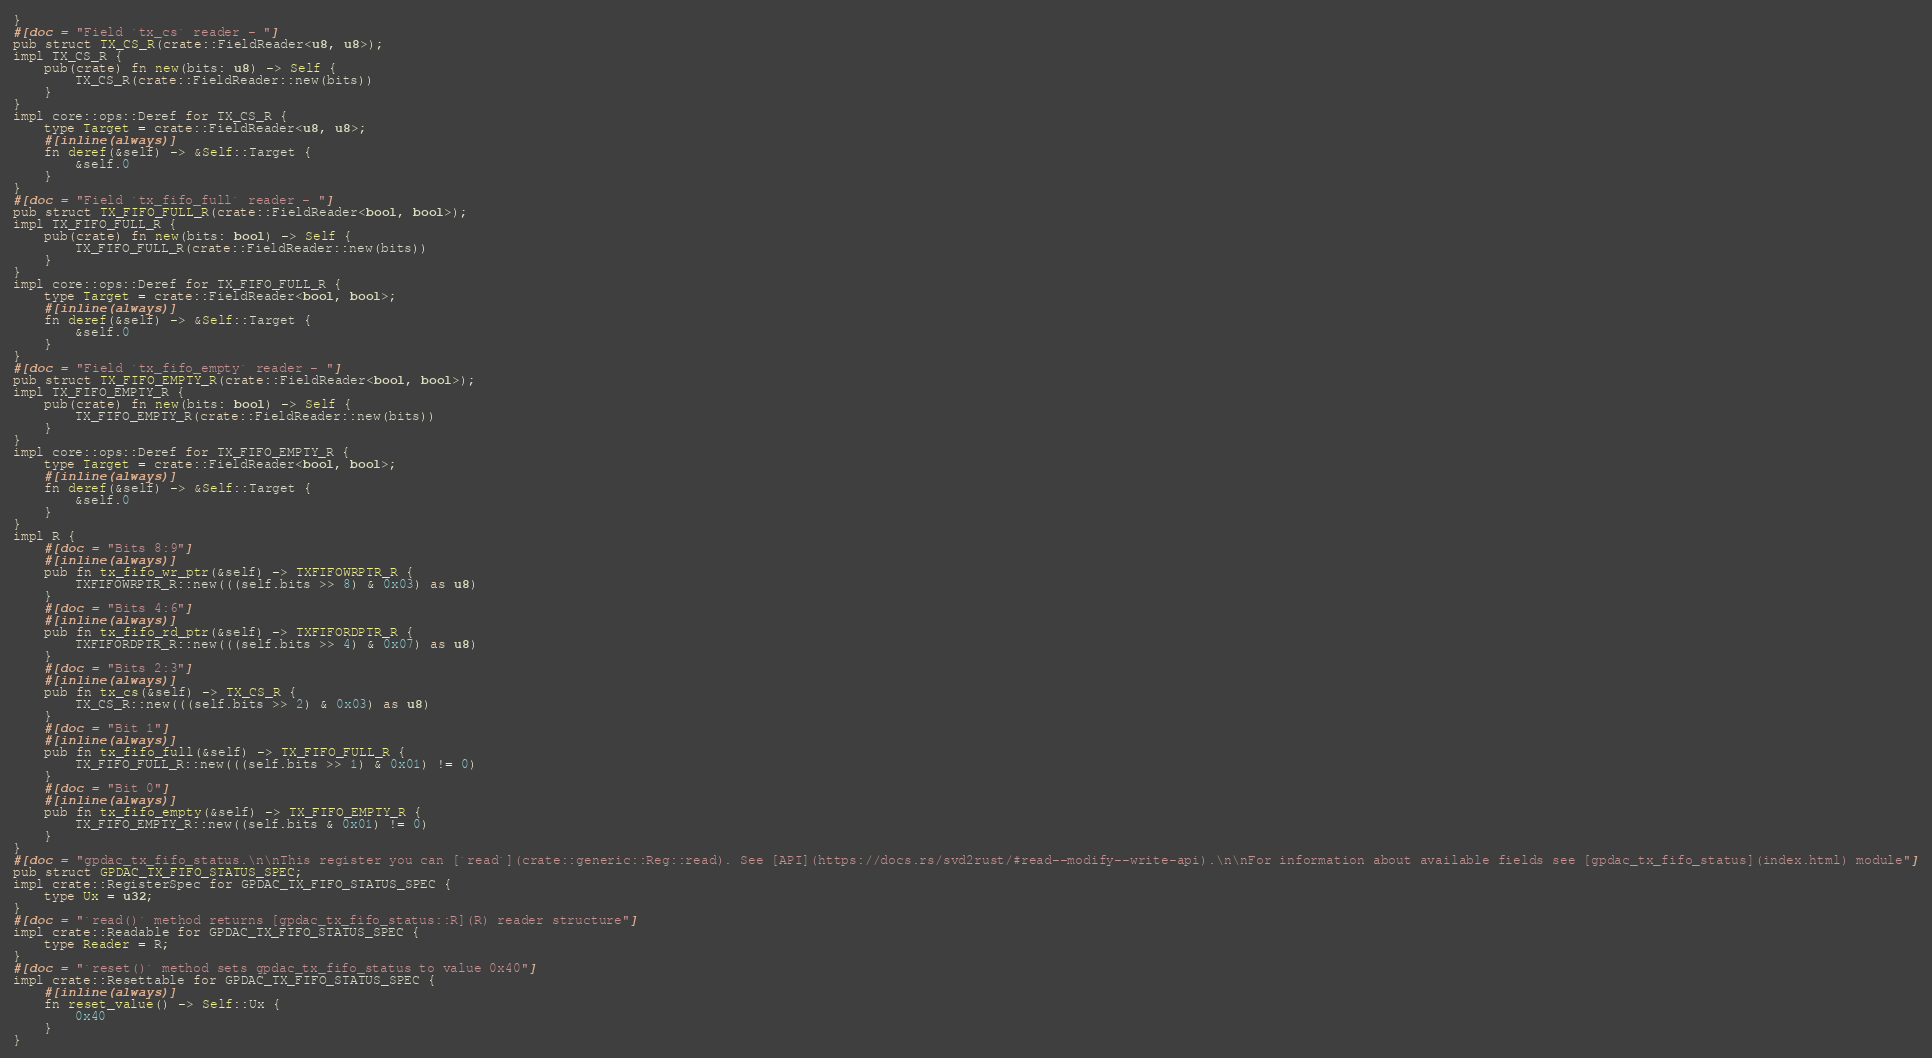<code> <loc_0><loc_0><loc_500><loc_500><_Rust_>}
#[doc = "Field `tx_cs` reader - "]
pub struct TX_CS_R(crate::FieldReader<u8, u8>);
impl TX_CS_R {
    pub(crate) fn new(bits: u8) -> Self {
        TX_CS_R(crate::FieldReader::new(bits))
    }
}
impl core::ops::Deref for TX_CS_R {
    type Target = crate::FieldReader<u8, u8>;
    #[inline(always)]
    fn deref(&self) -> &Self::Target {
        &self.0
    }
}
#[doc = "Field `tx_fifo_full` reader - "]
pub struct TX_FIFO_FULL_R(crate::FieldReader<bool, bool>);
impl TX_FIFO_FULL_R {
    pub(crate) fn new(bits: bool) -> Self {
        TX_FIFO_FULL_R(crate::FieldReader::new(bits))
    }
}
impl core::ops::Deref for TX_FIFO_FULL_R {
    type Target = crate::FieldReader<bool, bool>;
    #[inline(always)]
    fn deref(&self) -> &Self::Target {
        &self.0
    }
}
#[doc = "Field `tx_fifo_empty` reader - "]
pub struct TX_FIFO_EMPTY_R(crate::FieldReader<bool, bool>);
impl TX_FIFO_EMPTY_R {
    pub(crate) fn new(bits: bool) -> Self {
        TX_FIFO_EMPTY_R(crate::FieldReader::new(bits))
    }
}
impl core::ops::Deref for TX_FIFO_EMPTY_R {
    type Target = crate::FieldReader<bool, bool>;
    #[inline(always)]
    fn deref(&self) -> &Self::Target {
        &self.0
    }
}
impl R {
    #[doc = "Bits 8:9"]
    #[inline(always)]
    pub fn tx_fifo_wr_ptr(&self) -> TXFIFOWRPTR_R {
        TXFIFOWRPTR_R::new(((self.bits >> 8) & 0x03) as u8)
    }
    #[doc = "Bits 4:6"]
    #[inline(always)]
    pub fn tx_fifo_rd_ptr(&self) -> TXFIFORDPTR_R {
        TXFIFORDPTR_R::new(((self.bits >> 4) & 0x07) as u8)
    }
    #[doc = "Bits 2:3"]
    #[inline(always)]
    pub fn tx_cs(&self) -> TX_CS_R {
        TX_CS_R::new(((self.bits >> 2) & 0x03) as u8)
    }
    #[doc = "Bit 1"]
    #[inline(always)]
    pub fn tx_fifo_full(&self) -> TX_FIFO_FULL_R {
        TX_FIFO_FULL_R::new(((self.bits >> 1) & 0x01) != 0)
    }
    #[doc = "Bit 0"]
    #[inline(always)]
    pub fn tx_fifo_empty(&self) -> TX_FIFO_EMPTY_R {
        TX_FIFO_EMPTY_R::new((self.bits & 0x01) != 0)
    }
}
#[doc = "gpdac_tx_fifo_status.\n\nThis register you can [`read`](crate::generic::Reg::read). See [API](https://docs.rs/svd2rust/#read--modify--write-api).\n\nFor information about available fields see [gpdac_tx_fifo_status](index.html) module"]
pub struct GPDAC_TX_FIFO_STATUS_SPEC;
impl crate::RegisterSpec for GPDAC_TX_FIFO_STATUS_SPEC {
    type Ux = u32;
}
#[doc = "`read()` method returns [gpdac_tx_fifo_status::R](R) reader structure"]
impl crate::Readable for GPDAC_TX_FIFO_STATUS_SPEC {
    type Reader = R;
}
#[doc = "`reset()` method sets gpdac_tx_fifo_status to value 0x40"]
impl crate::Resettable for GPDAC_TX_FIFO_STATUS_SPEC {
    #[inline(always)]
    fn reset_value() -> Self::Ux {
        0x40
    }
}
</code> 